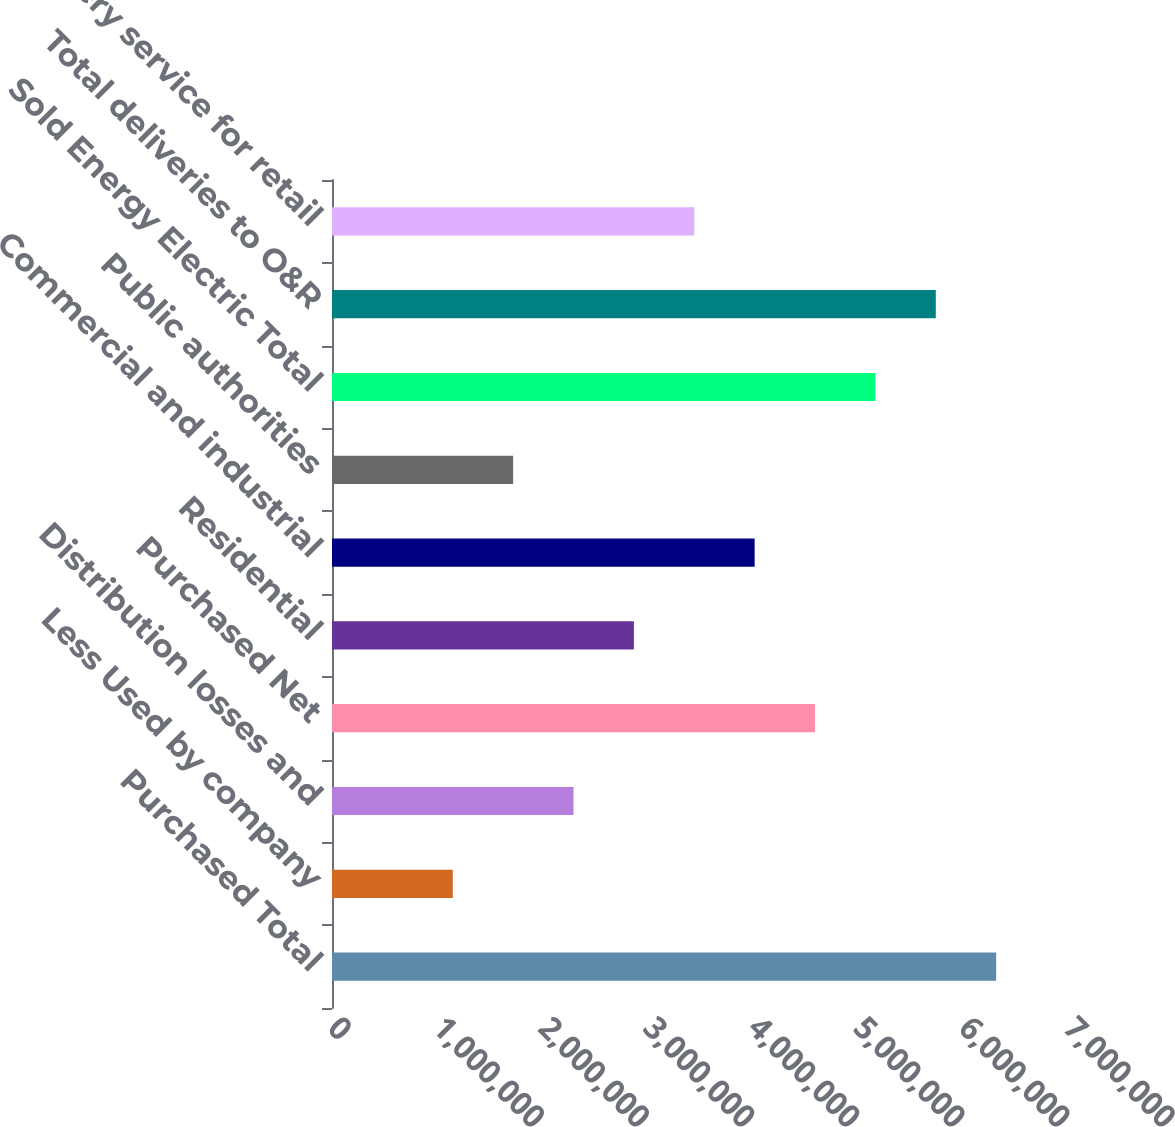Convert chart to OTSL. <chart><loc_0><loc_0><loc_500><loc_500><bar_chart><fcel>Purchased Total<fcel>Less Used by company<fcel>Distribution losses and<fcel>Purchased Net<fcel>Residential<fcel>Commercial and industrial<fcel>Public authorities<fcel>Sold Energy Electric Total<fcel>Total deliveries to O&R<fcel>Delivery service for retail<nl><fcel>6.31681e+06<fcel>1.14852e+06<fcel>2.29703e+06<fcel>4.59405e+06<fcel>2.87128e+06<fcel>4.01979e+06<fcel>1.72277e+06<fcel>5.1683e+06<fcel>5.74255e+06<fcel>3.44554e+06<nl></chart> 